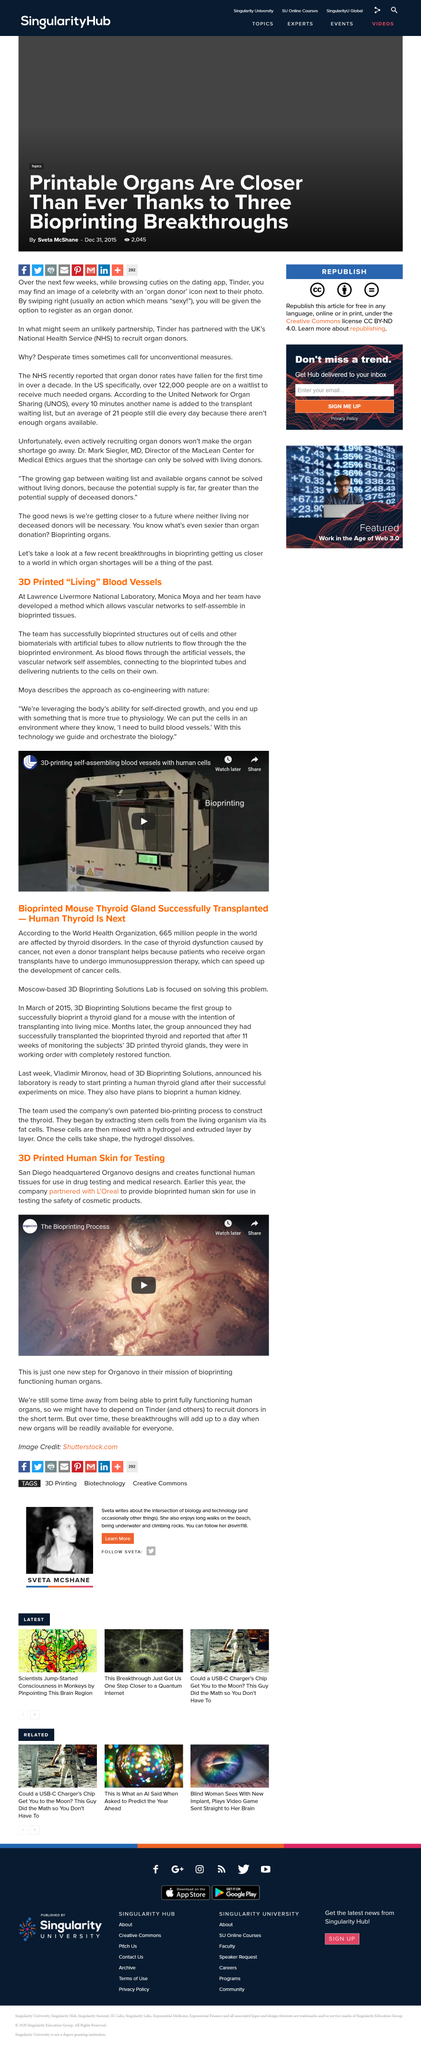Indicate a few pertinent items in this graphic. Bioprinting solutions have achieved success in printing a thyroid gland for a mouse, demonstrating the potential for this technology to produce functional human organs for medical applications. One cause of thyroid issues is cancer. Bio printing is a process in which a 3-D printer is used to create body parts using living cells. This technology allows for the creation of personalized organs and tissues for medical applications, such as the replacement of damaged or diseased tissues. The use of bio printing has the potential to revolutionize the field of medicine and greatly improve the lives of those in need of organ transplants. Our research team, led by Monica Moya, has developed a groundbreaking method that enables vascular networks to self-assemble in bioprinted tissues, which is a significant advancement in the field of tissue engineering and regenerative medicine. This method has the potential to revolutionize the way tissue bioprinting is done, by allowing for the creation of more complex and functional tissues with improved vasculature. The vascular network self-assembles as blood flows through the artificial vessels. 